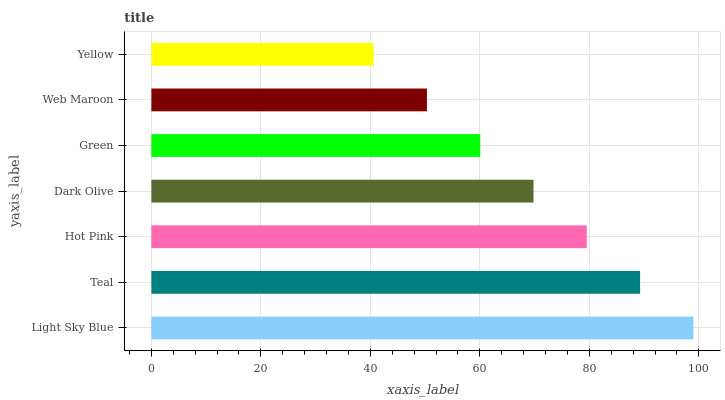Is Yellow the minimum?
Answer yes or no. Yes. Is Light Sky Blue the maximum?
Answer yes or no. Yes. Is Teal the minimum?
Answer yes or no. No. Is Teal the maximum?
Answer yes or no. No. Is Light Sky Blue greater than Teal?
Answer yes or no. Yes. Is Teal less than Light Sky Blue?
Answer yes or no. Yes. Is Teal greater than Light Sky Blue?
Answer yes or no. No. Is Light Sky Blue less than Teal?
Answer yes or no. No. Is Dark Olive the high median?
Answer yes or no. Yes. Is Dark Olive the low median?
Answer yes or no. Yes. Is Light Sky Blue the high median?
Answer yes or no. No. Is Web Maroon the low median?
Answer yes or no. No. 